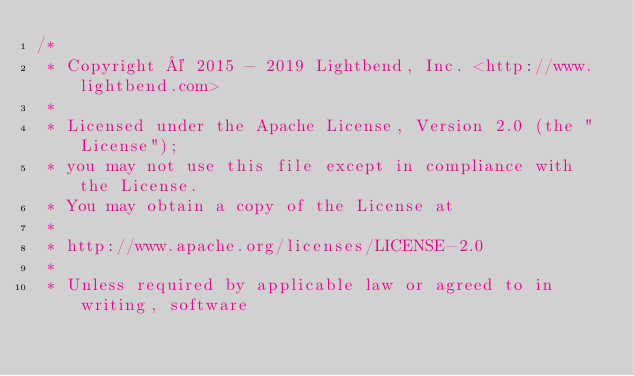Convert code to text. <code><loc_0><loc_0><loc_500><loc_500><_Scala_>/*
 * Copyright © 2015 - 2019 Lightbend, Inc. <http://www.lightbend.com>
 *
 * Licensed under the Apache License, Version 2.0 (the "License");
 * you may not use this file except in compliance with the License.
 * You may obtain a copy of the License at
 *
 * http://www.apache.org/licenses/LICENSE-2.0
 *
 * Unless required by applicable law or agreed to in writing, software</code> 